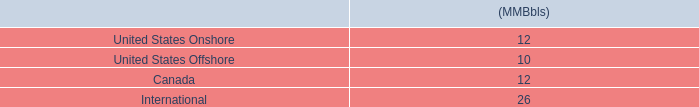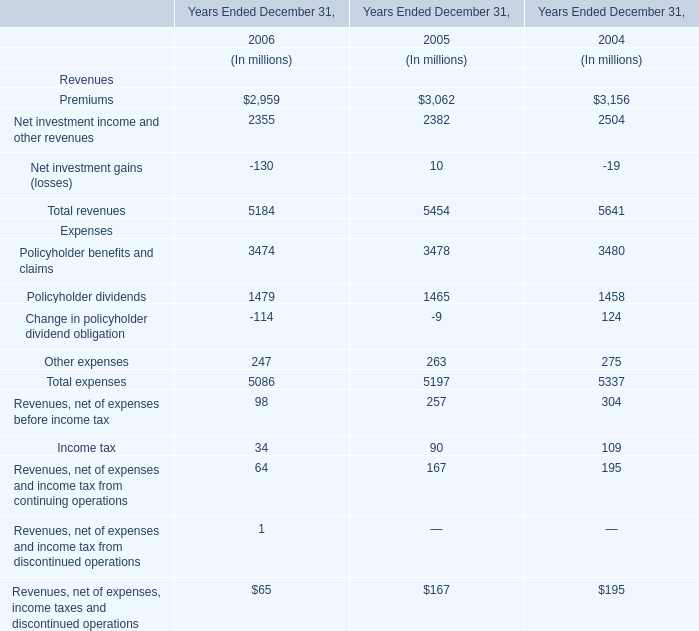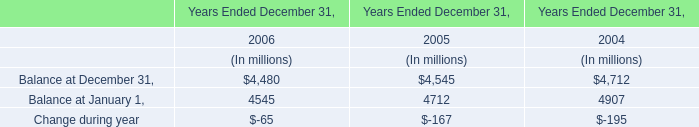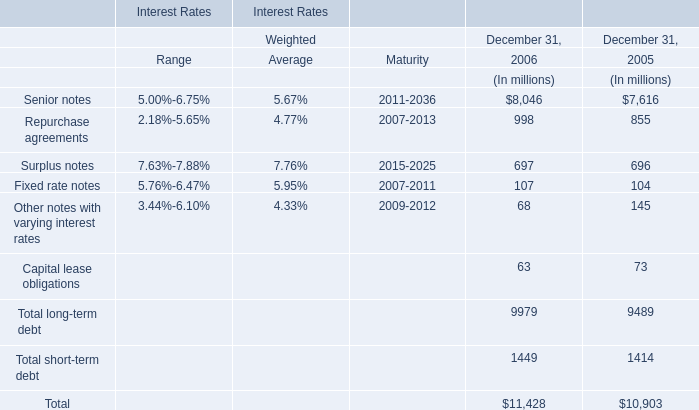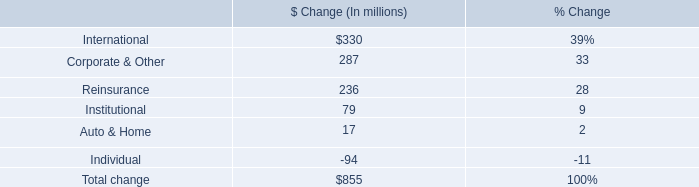What is the sum of the Balance at January 1, in the years where Balance at December 31, greater than 4500? (in million) 
Computations: (4712 + 4907)
Answer: 9619.0. 